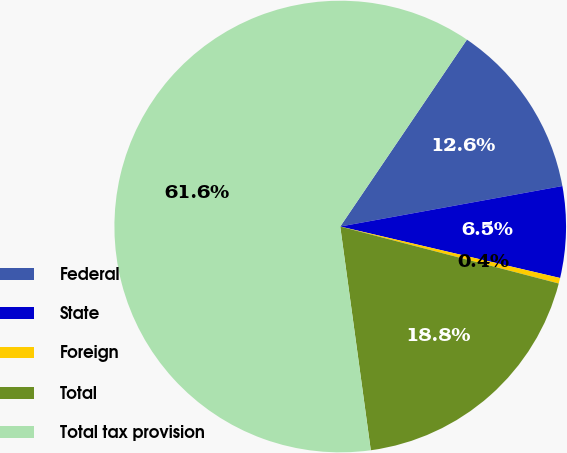Convert chart. <chart><loc_0><loc_0><loc_500><loc_500><pie_chart><fcel>Federal<fcel>State<fcel>Foreign<fcel>Total<fcel>Total tax provision<nl><fcel>12.65%<fcel>6.53%<fcel>0.4%<fcel>18.78%<fcel>61.64%<nl></chart> 